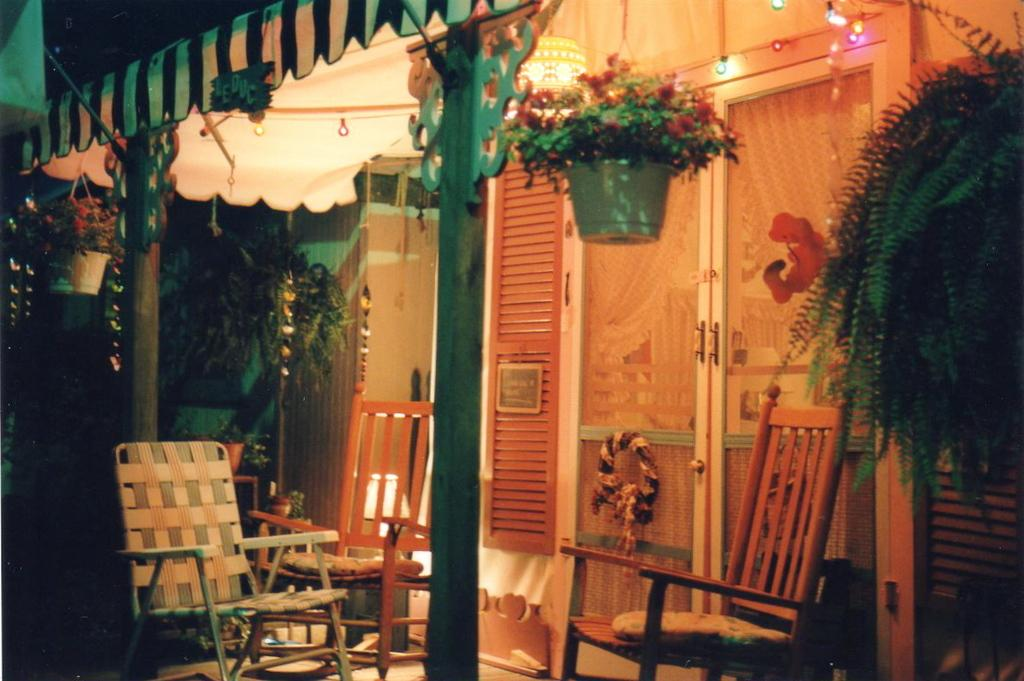What type of objects can be seen in the image? There are pots, chairs, a door, a shelter, lights, plants, a wall, and a flower bouquet in the image. Can you describe the shelter in the image? The shelter is likely a structure that provides protection from the elements, such as a gazebo or a covered patio. What might the lights be used for in the image? The lights could be used for illumination, either for practical purposes or to create a specific ambiance. Are there any natural elements present in the image? Yes, there are plants in the image, which are a natural element. Where is the bear located in the image? There is no bear present in the image. What type of shade does the jar provide in the image? There is no jar or shade present in the image. 